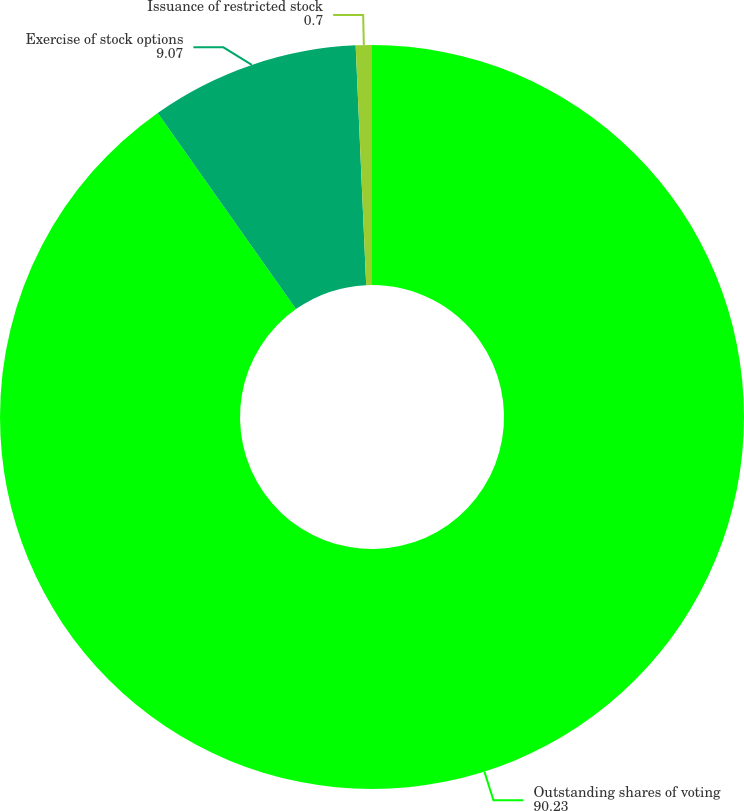Convert chart to OTSL. <chart><loc_0><loc_0><loc_500><loc_500><pie_chart><fcel>Outstanding shares of voting<fcel>Exercise of stock options<fcel>Issuance of restricted stock<nl><fcel>90.23%<fcel>9.07%<fcel>0.7%<nl></chart> 